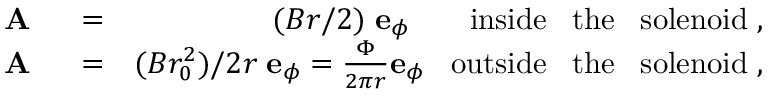<formula> <loc_0><loc_0><loc_500><loc_500>\begin{array} { r l r } { A } & = } & { ( B r / 2 ) \, { e } _ { \phi } \, i n s i d e \, t h e \, s o l e n o i d \, , } \\ { A } & = } & { ( B r _ { 0 } ^ { 2 } ) / 2 r \, { e } _ { \phi } = \frac { \Phi } { 2 \pi r } { e } _ { \phi } \, o u t s i d e \, t h e \, s o l e n o i d \, , } \end{array}</formula> 